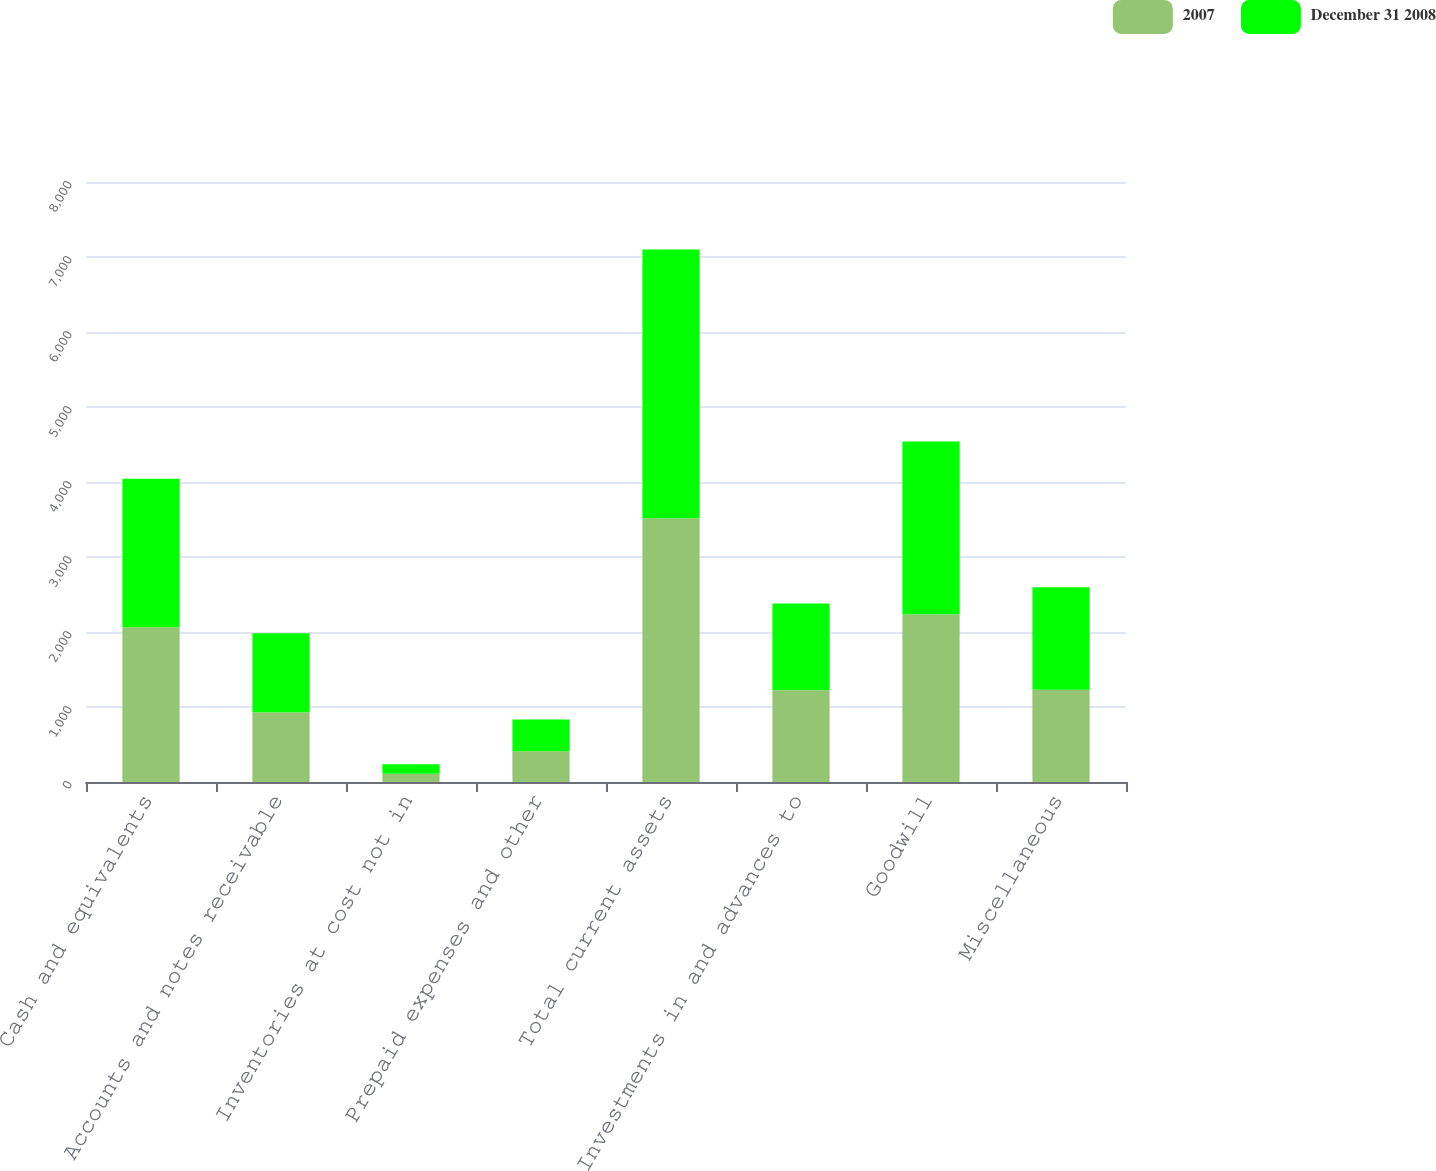Convert chart. <chart><loc_0><loc_0><loc_500><loc_500><stacked_bar_chart><ecel><fcel>Cash and equivalents<fcel>Accounts and notes receivable<fcel>Inventories at cost not in<fcel>Prepaid expenses and other<fcel>Total current assets<fcel>Investments in and advances to<fcel>Goodwill<fcel>Miscellaneous<nl><fcel>2007<fcel>2063.4<fcel>931.2<fcel>111.5<fcel>411.5<fcel>3517.6<fcel>1222.3<fcel>2237.4<fcel>1229.7<nl><fcel>December 31 2008<fcel>1981.3<fcel>1053.8<fcel>125.3<fcel>421.5<fcel>3581.9<fcel>1156.4<fcel>2301.3<fcel>1367.4<nl></chart> 